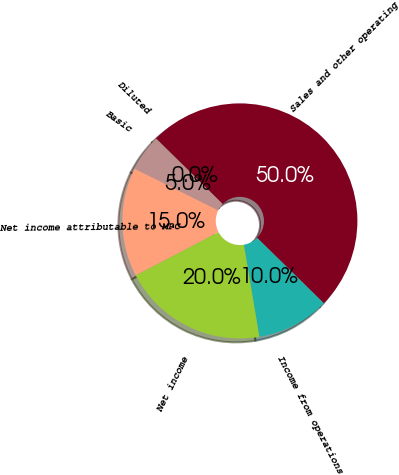Convert chart to OTSL. <chart><loc_0><loc_0><loc_500><loc_500><pie_chart><fcel>Sales and other operating<fcel>Income from operations<fcel>Net income<fcel>Net income attributable to MPC<fcel>Basic<fcel>Diluted<nl><fcel>49.98%<fcel>10.0%<fcel>20.0%<fcel>15.0%<fcel>5.01%<fcel>0.01%<nl></chart> 